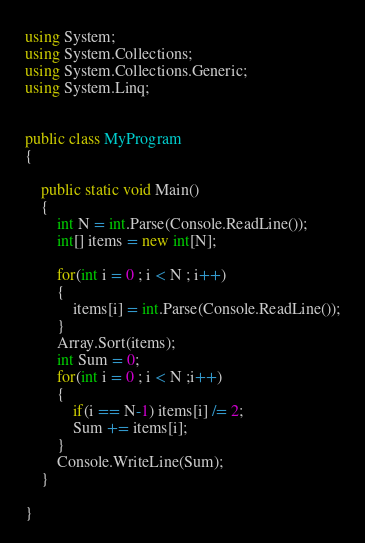<code> <loc_0><loc_0><loc_500><loc_500><_C#_>using System;
using System.Collections;
using System.Collections.Generic;
using System.Linq;


public class MyProgram
{	
  
    public static void Main()
	{
        int N = int.Parse(Console.ReadLine());
        int[] items = new int[N];
    
        for(int i = 0 ; i < N ; i++)
        {
            items[i] = int.Parse(Console.ReadLine());
        }
        Array.Sort(items);
        int Sum = 0;
        for(int i = 0 ; i < N ;i++)
        {
            if(i == N-1) items[i] /= 2;
            Sum += items[i];
        }
        Console.WriteLine(Sum);
    }
    
}</code> 